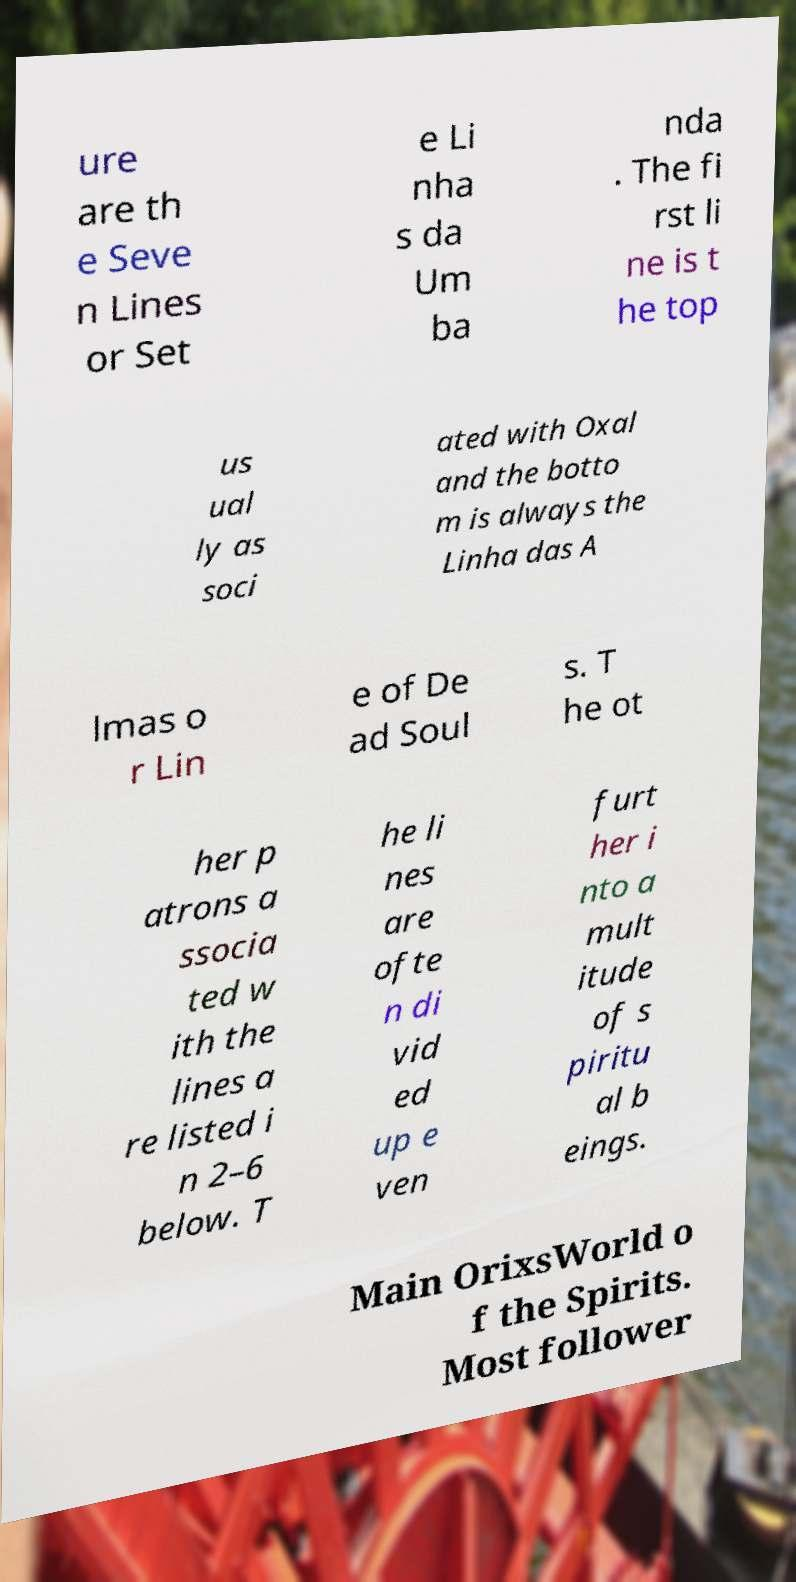What messages or text are displayed in this image? I need them in a readable, typed format. ure are th e Seve n Lines or Set e Li nha s da Um ba nda . The fi rst li ne is t he top us ual ly as soci ated with Oxal and the botto m is always the Linha das A lmas o r Lin e of De ad Soul s. T he ot her p atrons a ssocia ted w ith the lines a re listed i n 2–6 below. T he li nes are ofte n di vid ed up e ven furt her i nto a mult itude of s piritu al b eings. Main OrixsWorld o f the Spirits. Most follower 